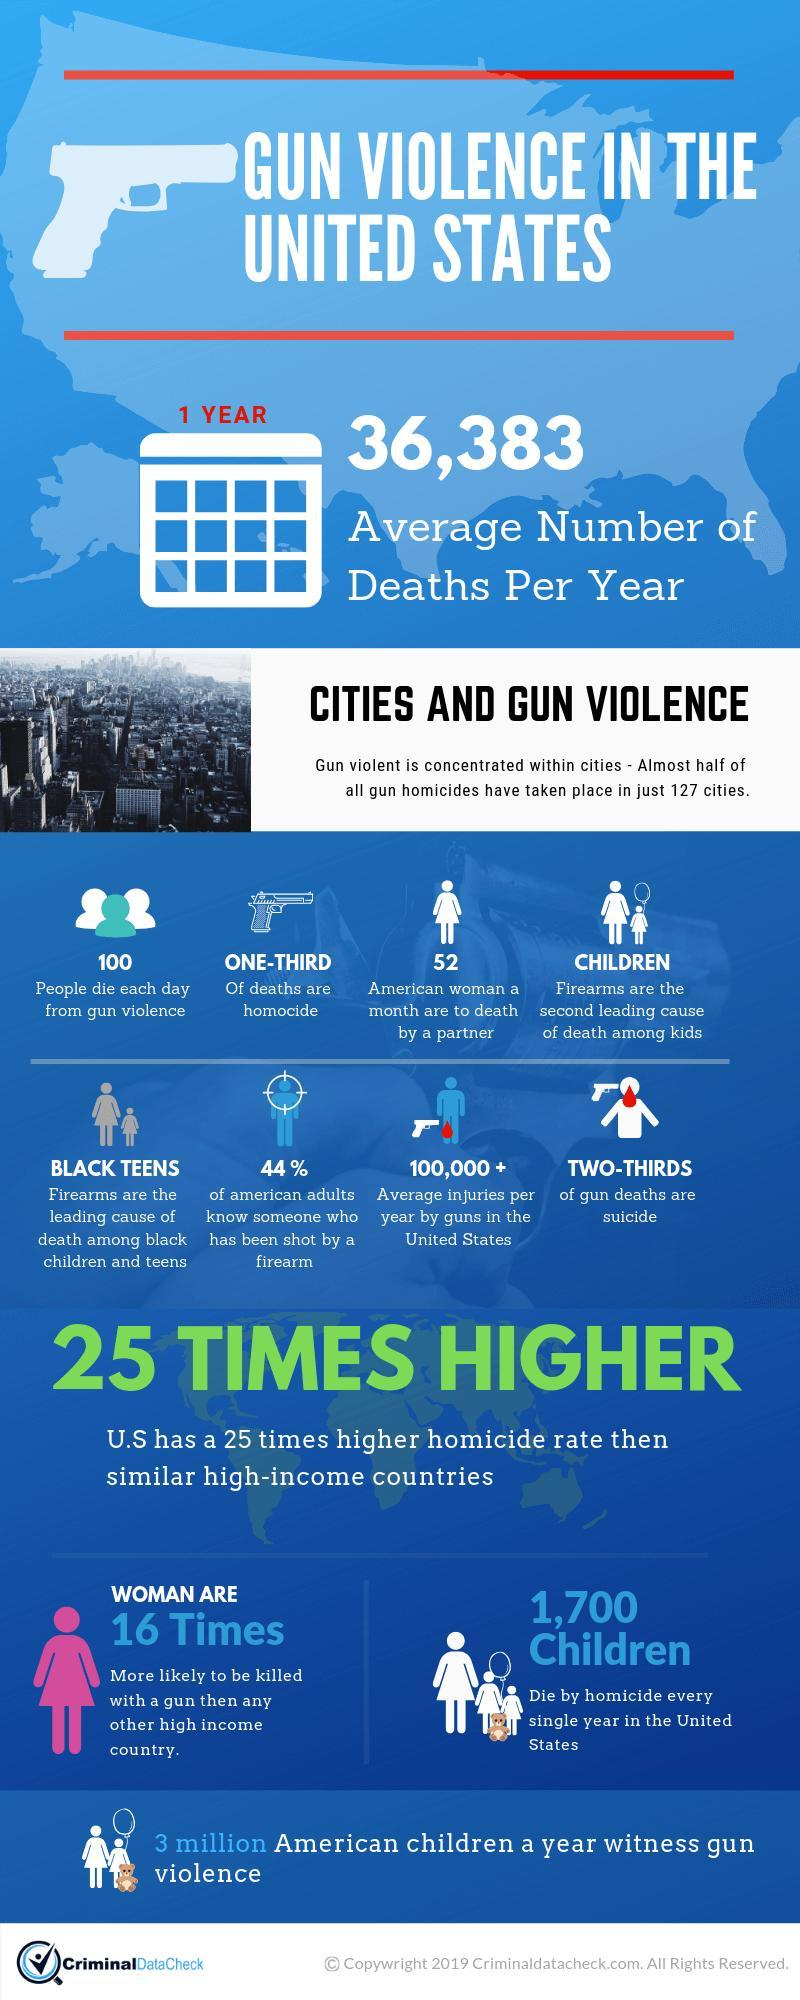What percentage of American adults do not know anyone who has been shot by a firearm?
Answer the question with a short phrase. 56 How many American women are put to death by a partner per month? 52 